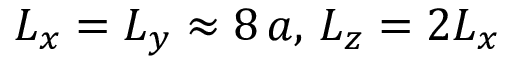Convert formula to latex. <formula><loc_0><loc_0><loc_500><loc_500>L _ { x } = L _ { y } \approx 8 \, a , \, L _ { z } = 2 L _ { x }</formula> 